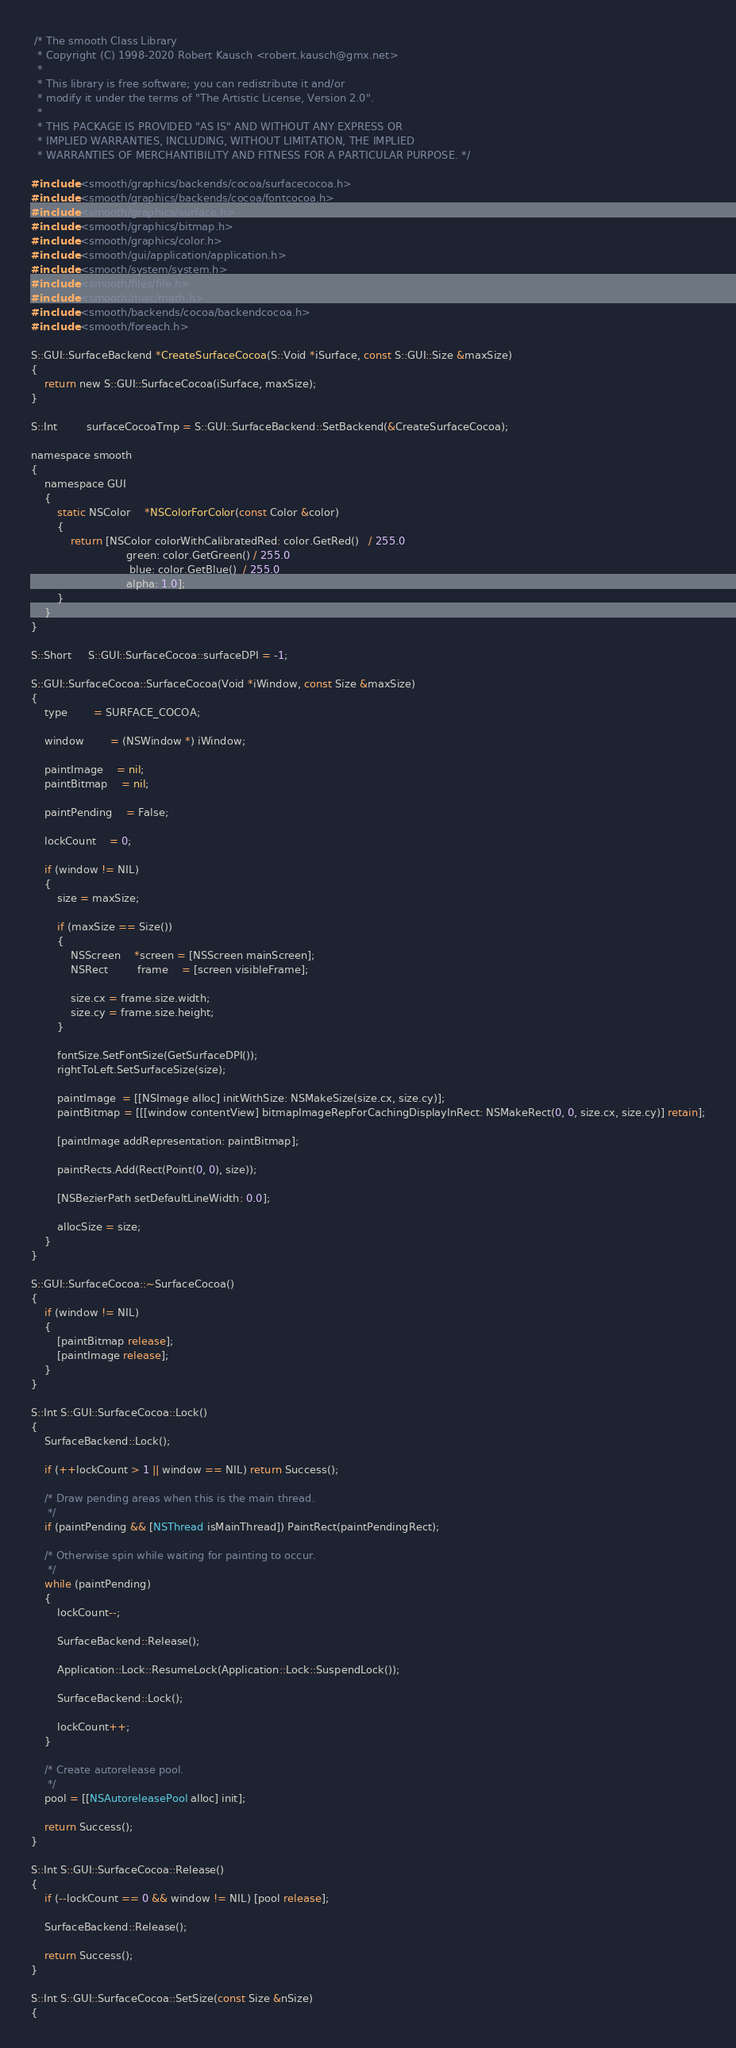<code> <loc_0><loc_0><loc_500><loc_500><_ObjectiveC_> /* The smooth Class Library
  * Copyright (C) 1998-2020 Robert Kausch <robert.kausch@gmx.net>
  *
  * This library is free software; you can redistribute it and/or
  * modify it under the terms of "The Artistic License, Version 2.0".
  *
  * THIS PACKAGE IS PROVIDED "AS IS" AND WITHOUT ANY EXPRESS OR
  * IMPLIED WARRANTIES, INCLUDING, WITHOUT LIMITATION, THE IMPLIED
  * WARRANTIES OF MERCHANTIBILITY AND FITNESS FOR A PARTICULAR PURPOSE. */

#include <smooth/graphics/backends/cocoa/surfacecocoa.h>
#include <smooth/graphics/backends/cocoa/fontcocoa.h>
#include <smooth/graphics/surface.h>
#include <smooth/graphics/bitmap.h>
#include <smooth/graphics/color.h>
#include <smooth/gui/application/application.h>
#include <smooth/system/system.h>
#include <smooth/files/file.h>
#include <smooth/misc/math.h>
#include <smooth/backends/cocoa/backendcocoa.h>
#include <smooth/foreach.h>

S::GUI::SurfaceBackend *CreateSurfaceCocoa(S::Void *iSurface, const S::GUI::Size &maxSize)
{
	return new S::GUI::SurfaceCocoa(iSurface, maxSize);
}

S::Int		 surfaceCocoaTmp = S::GUI::SurfaceBackend::SetBackend(&CreateSurfaceCocoa);

namespace smooth
{
	namespace GUI
	{
		static NSColor	*NSColorForColor(const Color &color)
		{
			return [NSColor colorWithCalibratedRed: color.GetRed()   / 255.0
							 green: color.GetGreen() / 255.0
							  blue: color.GetBlue()  / 255.0
							 alpha: 1.0];
		}
	}
}

S::Short	 S::GUI::SurfaceCocoa::surfaceDPI = -1;

S::GUI::SurfaceCocoa::SurfaceCocoa(Void *iWindow, const Size &maxSize)
{
	type		= SURFACE_COCOA;

	window		= (NSWindow *) iWindow;

	paintImage	= nil;
	paintBitmap	= nil;

	paintPending	= False;

	lockCount	= 0;

	if (window != NIL)
	{
		size = maxSize;

		if (maxSize == Size())
		{
			NSScreen	*screen = [NSScreen mainScreen];
			NSRect		 frame	= [screen visibleFrame];

			size.cx = frame.size.width;
			size.cy = frame.size.height;
		}

		fontSize.SetFontSize(GetSurfaceDPI());
		rightToLeft.SetSurfaceSize(size);

		paintImage  = [[NSImage alloc] initWithSize: NSMakeSize(size.cx, size.cy)];
		paintBitmap = [[[window contentView] bitmapImageRepForCachingDisplayInRect: NSMakeRect(0, 0, size.cx, size.cy)] retain];

		[paintImage addRepresentation: paintBitmap];

		paintRects.Add(Rect(Point(0, 0), size));

		[NSBezierPath setDefaultLineWidth: 0.0];

		allocSize = size;
	}
}

S::GUI::SurfaceCocoa::~SurfaceCocoa()
{
	if (window != NIL)
	{
		[paintBitmap release];
		[paintImage release];
	}
}

S::Int S::GUI::SurfaceCocoa::Lock()
{
	SurfaceBackend::Lock();

	if (++lockCount > 1 || window == NIL) return Success();

	/* Draw pending areas when this is the main thread.
	 */
	if (paintPending && [NSThread isMainThread]) PaintRect(paintPendingRect);

	/* Otherwise spin while waiting for painting to occur.
	 */
	while (paintPending)
	{
		lockCount--;

		SurfaceBackend::Release();

		Application::Lock::ResumeLock(Application::Lock::SuspendLock());

		SurfaceBackend::Lock();

		lockCount++;
	}

	/* Create autorelease pool.
	 */
	pool = [[NSAutoreleasePool alloc] init];

	return Success();
}

S::Int S::GUI::SurfaceCocoa::Release()
{
	if (--lockCount == 0 && window != NIL) [pool release];

	SurfaceBackend::Release();

	return Success();
}

S::Int S::GUI::SurfaceCocoa::SetSize(const Size &nSize)
{</code> 